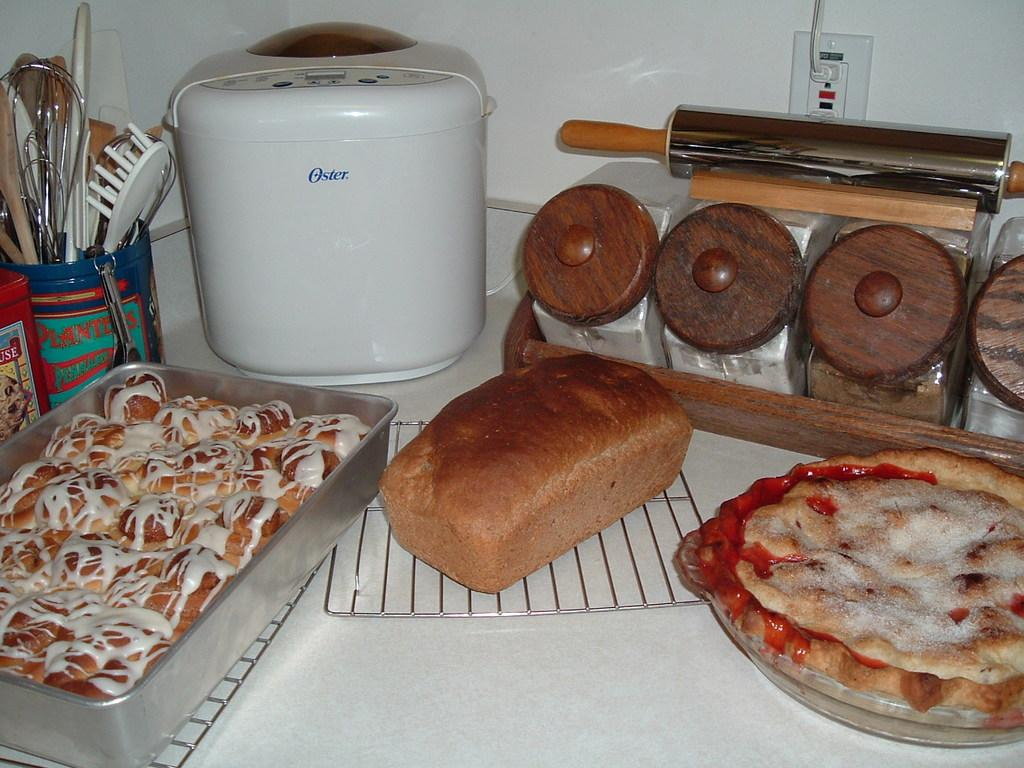<image>
Describe the image concisely. Pizza, bread and cinnamon rolls on top of the counter with an Oster device. 